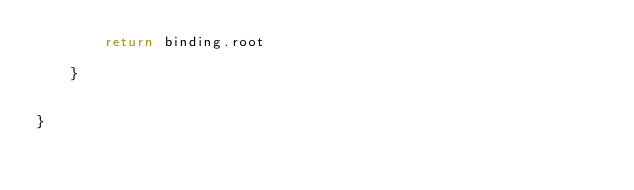<code> <loc_0><loc_0><loc_500><loc_500><_Kotlin_>        return binding.root

    }


}
</code> 